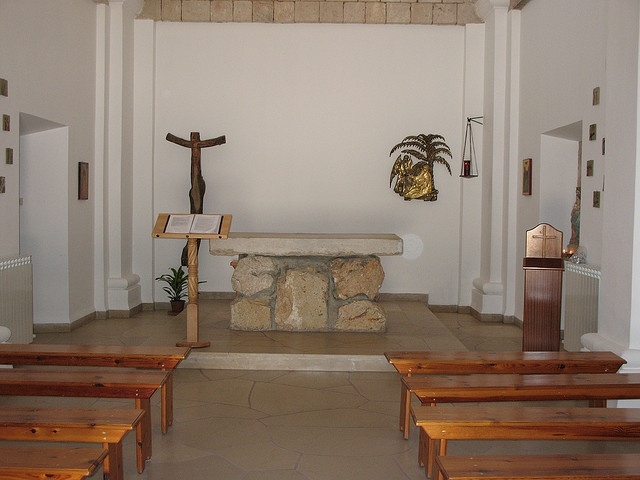Describe the objects in this image and their specific colors. I can see bench in gray, maroon, and brown tones, bench in gray, maroon, and brown tones, bench in gray, maroon, and brown tones, bench in gray and maroon tones, and bench in gray, maroon, and brown tones in this image. 